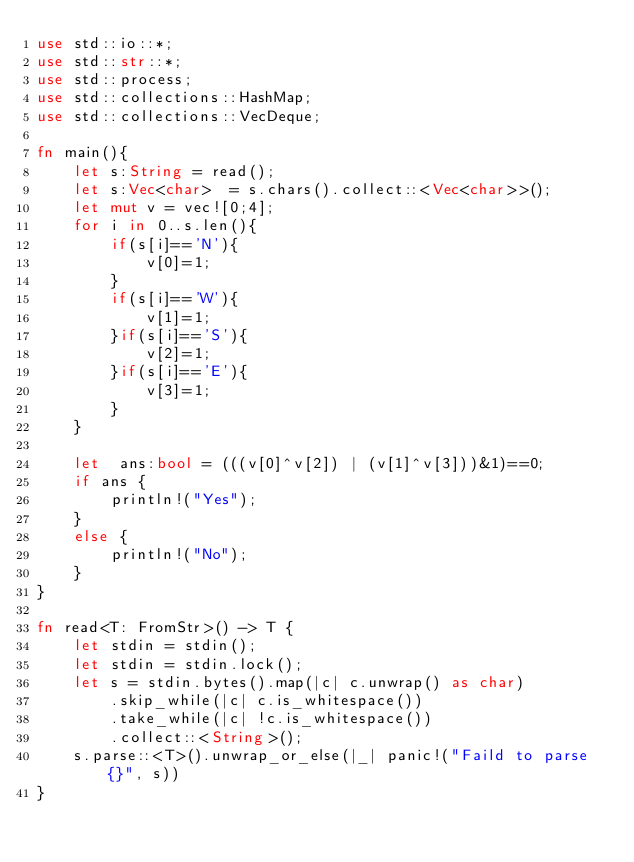<code> <loc_0><loc_0><loc_500><loc_500><_Rust_>use std::io::*;
use std::str::*;
use std::process;
use std::collections::HashMap;
use std::collections::VecDeque;

fn main(){
    let s:String = read();
    let s:Vec<char>  = s.chars().collect::<Vec<char>>();
    let mut v = vec![0;4];
    for i in 0..s.len(){
        if(s[i]=='N'){
            v[0]=1;
        }
        if(s[i]=='W'){
            v[1]=1;
        }if(s[i]=='S'){
            v[2]=1;
        }if(s[i]=='E'){
            v[3]=1;
        }
    }

    let  ans:bool = (((v[0]^v[2]) | (v[1]^v[3]))&1)==0;
    if ans {
        println!("Yes");
    }
    else {
        println!("No");
    }
}

fn read<T: FromStr>() -> T {
    let stdin = stdin();
    let stdin = stdin.lock();
    let s = stdin.bytes().map(|c| c.unwrap() as char)
        .skip_while(|c| c.is_whitespace())
        .take_while(|c| !c.is_whitespace())
        .collect::<String>();
    s.parse::<T>().unwrap_or_else(|_| panic!("Faild to parse {}", s))
}
</code> 